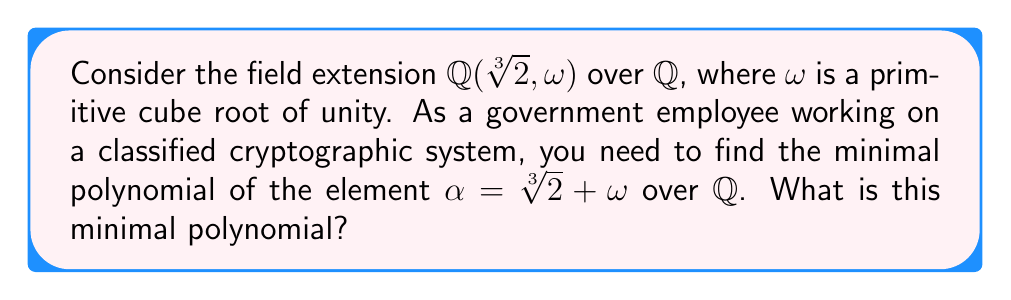Show me your answer to this math problem. Let's approach this step-by-step:

1) First, we need to understand the structure of our field extension. $\mathbb{Q}(\sqrt[3]{2}, \omega)$ is a degree 6 extension over $\mathbb{Q}$.

2) We know that $\omega$ satisfies $x^2 + x + 1 = 0$, so $\omega^2 = -\omega - 1$.

3) Let's consider the conjugates of $\alpha$:
   $\alpha_1 = \sqrt[3]{2} + \omega$
   $\alpha_2 = \sqrt[3]{2} + \omega^2$
   $\alpha_3 = \omega\sqrt[3]{2} + \omega^2$
   $\alpha_4 = \omega\sqrt[3]{2} + 1$
   $\alpha_5 = \omega^2\sqrt[3]{2} + \omega$
   $\alpha_6 = \omega^2\sqrt[3]{2} + 1$

4) The minimal polynomial of $\alpha$ will be:
   $m(x) = (x - \alpha_1)(x - \alpha_2)(x - \alpha_3)(x - \alpha_4)(x - \alpha_5)(x - \alpha_6)$

5) Let's calculate the coefficients of this polynomial:

   Sum of roots: $\alpha_1 + \alpha_2 + \alpha_3 + \alpha_4 + \alpha_5 + \alpha_6 = 0$

   Sum of products of roots taken two at a time:
   $\sum \alpha_i\alpha_j = -6$

   Sum of products of roots taken three at a time:
   $\sum \alpha_i\alpha_j\alpha_k = 0$

   Sum of products of roots taken four at a time:
   $\sum \alpha_i\alpha_j\alpha_k\alpha_l = 9$

   Sum of products of roots taken five at a time:
   $\sum \alpha_i\alpha_j\alpha_k\alpha_l\alpha_m = 0$

   Product of all roots:
   $\alpha_1\alpha_2\alpha_3\alpha_4\alpha_5\alpha_6 = -9$

6) Therefore, the minimal polynomial is:
   $m(x) = x^6 + 6x^4 - 9x^2 - 9$
Answer: $x^6 + 6x^4 - 9x^2 - 9$ 